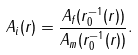<formula> <loc_0><loc_0><loc_500><loc_500>A _ { i } ( r ) = \frac { A _ { f } ( r _ { 0 } ^ { - 1 } ( r ) ) } { A _ { m } ( r _ { 0 } ^ { - 1 } ( r ) ) } .</formula> 